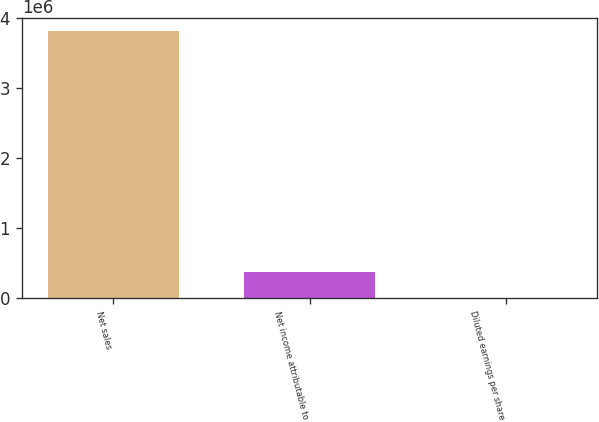Convert chart to OTSL. <chart><loc_0><loc_0><loc_500><loc_500><bar_chart><fcel>Net sales<fcel>Net income attributable to<fcel>Diluted earnings per share<nl><fcel>3.81748e+06<fcel>381750<fcel>2.62<nl></chart> 